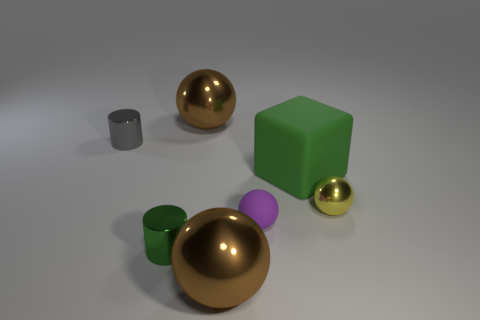What is the size of the metal cylinder that is the same color as the large matte thing?
Provide a succinct answer. Small. Is the number of tiny green cylinders right of the large green matte thing less than the number of brown balls?
Your answer should be very brief. Yes. What is the size of the gray metallic cylinder that is to the left of the green cylinder?
Offer a very short reply. Small. There is another small thing that is the same shape as the purple matte thing; what color is it?
Your answer should be very brief. Yellow. What number of large balls are the same color as the matte block?
Ensure brevity in your answer.  0. Are there any other things that are the same shape as the green matte object?
Your response must be concise. No. There is a big thing that is behind the small metallic thing that is behind the tiny yellow metal thing; are there any tiny objects that are behind it?
Offer a terse response. No. What number of green cylinders have the same material as the big cube?
Give a very brief answer. 0. There is a brown ball in front of the small green shiny cylinder; is its size the same as the metallic cylinder that is to the left of the tiny green object?
Provide a succinct answer. No. What color is the big ball on the right side of the brown thing to the left of the metallic object in front of the green cylinder?
Your response must be concise. Brown. 